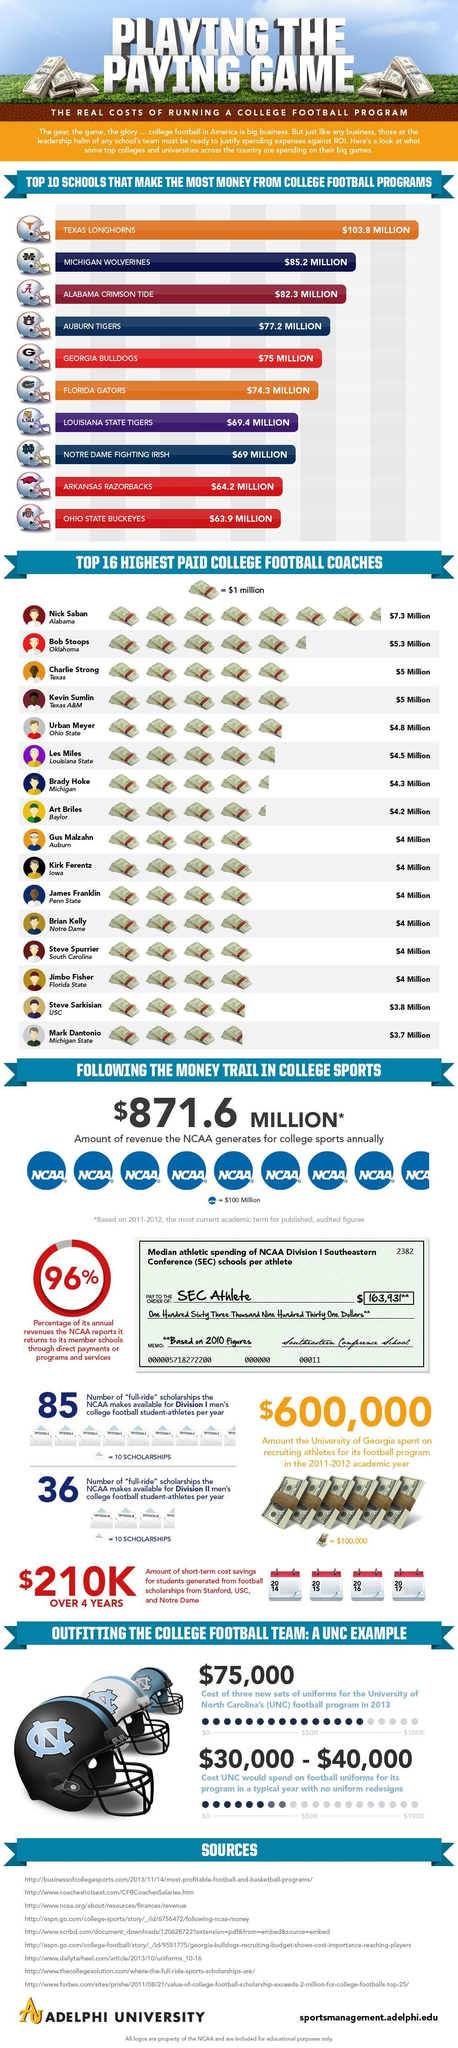What is the total number of money Texas Longhorns and Michigan Wolverines together make from college football programs?
Answer the question with a short phrase. $189 million What is the payment of Nick Saban and Bob Stoops, taken together? $12.6 million What is the cost of three new sets of uniforms for the University of North Carolina's football program in 2013? $75,000 What is the payment of Art Briles and Kirk Ferentz, taken together? $8.2 million What is the total number of money Florida Gators and Auburn Tigers together make from college football programs? $151.5 million 